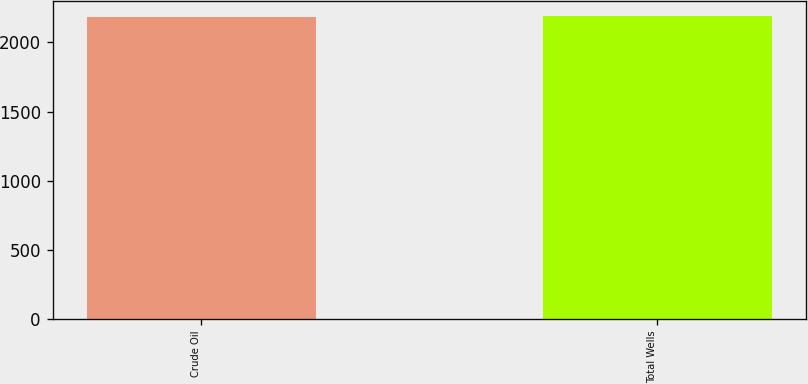<chart> <loc_0><loc_0><loc_500><loc_500><bar_chart><fcel>Crude Oil<fcel>Total Wells<nl><fcel>2187<fcel>2192<nl></chart> 